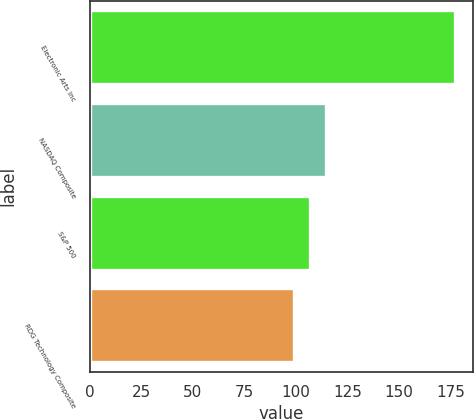Convert chart. <chart><loc_0><loc_0><loc_500><loc_500><bar_chart><fcel>Electronic Arts Inc<fcel>NASDAQ Composite<fcel>S&P 500<fcel>RDG Technology Composite<nl><fcel>177<fcel>114.6<fcel>106.8<fcel>99<nl></chart> 